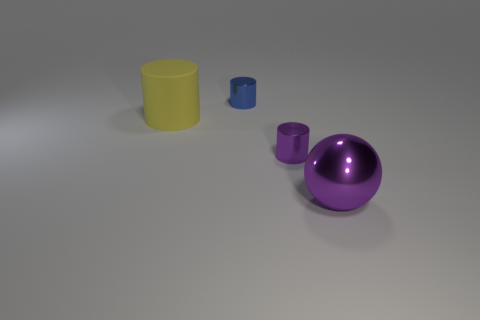Add 1 purple objects. How many objects exist? 5 Subtract all balls. How many objects are left? 3 Subtract all large objects. Subtract all large purple objects. How many objects are left? 1 Add 3 big metal objects. How many big metal objects are left? 4 Add 4 cylinders. How many cylinders exist? 7 Subtract 1 purple balls. How many objects are left? 3 